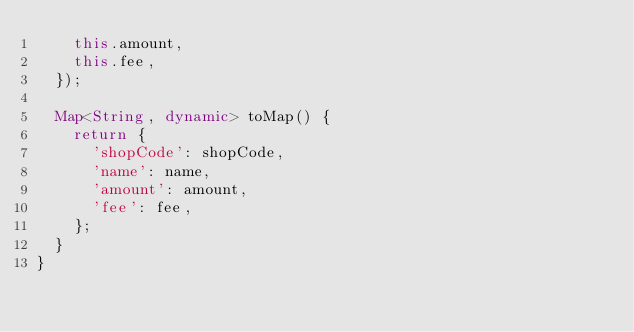Convert code to text. <code><loc_0><loc_0><loc_500><loc_500><_Dart_>    this.amount,
    this.fee,
  });

  Map<String, dynamic> toMap() {
    return {
      'shopCode': shopCode,
      'name': name,
      'amount': amount,
      'fee': fee,
    };
  }
}
</code> 